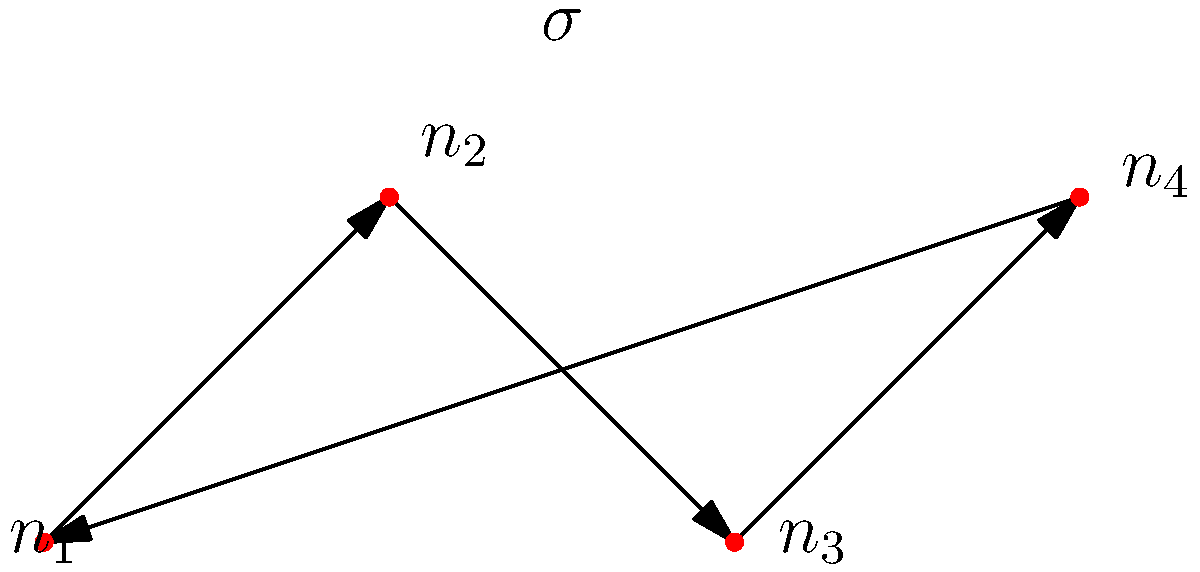Consider the neural circuit represented by the graph, where nodes represent neurons and directed edges represent synaptic connections. If we apply the permutation $\sigma = (1\,2\,3\,4)$ to this circuit, how many neurons will maintain their original outgoing synaptic connection? To solve this problem, we need to follow these steps:

1) First, let's understand what the permutation $\sigma = (1\,2\,3\,4)$ means:
   - Neuron 1 moves to position 2
   - Neuron 2 moves to position 3
   - Neuron 3 moves to position 4
   - Neuron 4 moves to position 1

2) Now, let's examine the original connections:
   - $n_1$ connects to $n_2$
   - $n_2$ connects to $n_3$
   - $n_3$ connects to $n_4$
   - $n_4$ connects to $n_1$

3) After applying the permutation:
   - The neuron at position 1 (originally $n_4$) now connects to the neuron at position 2 (originally $n_1$)
   - The neuron at position 2 (originally $n_1$) now connects to the neuron at position 3 (originally $n_2$)
   - The neuron at position 3 (originally $n_2$) now connects to the neuron at position 4 (originally $n_3$)
   - The neuron at position 4 (originally $n_3$) now connects to the neuron at position 1 (originally $n_4$)

4) Comparing the connections before and after:
   - $n_1$: originally connected to $n_2$, now connects to $n_2$ (maintained)
   - $n_2$: originally connected to $n_3$, now connects to $n_3$ (maintained)
   - $n_3$: originally connected to $n_4$, now connects to $n_4$ (maintained)
   - $n_4$: originally connected to $n_1$, now connects to $n_1$ (maintained)

5) Therefore, all four neurons maintain their original outgoing synaptic connection.
Answer: 4 